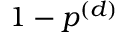Convert formula to latex. <formula><loc_0><loc_0><loc_500><loc_500>1 - p ^ { ( d ) }</formula> 